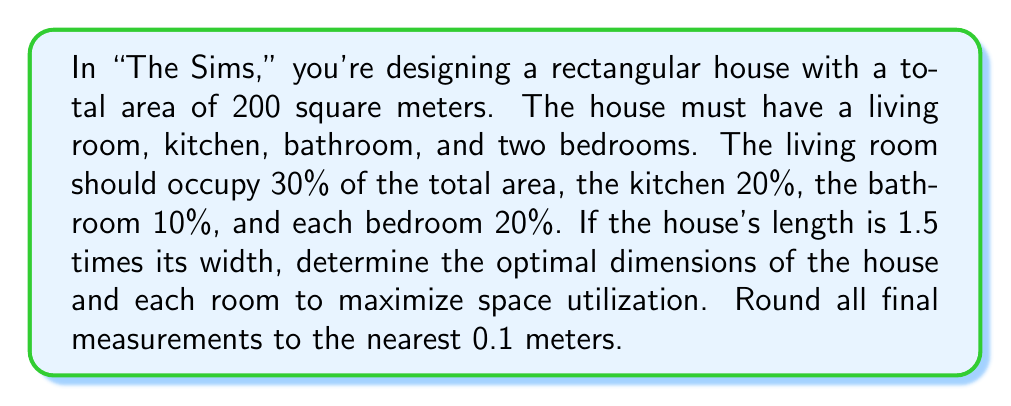Could you help me with this problem? Let's approach this step-by-step:

1) Let the width of the house be $w$ and the length be $l$. We know that:
   $l = 1.5w$

2) The area of the house is given by:
   $A = l \times w = 1.5w \times w = 1.5w^2 = 200$

3) Solving for $w$:
   $w^2 = \frac{200}{1.5} \approx 133.33$
   $w = \sqrt{133.33} \approx 11.5$ meters

4) The length $l$ is then:
   $l = 1.5w = 1.5 \times 11.5 = 17.3$ meters

5) Now, let's calculate the areas of each room:
   Living room: $30\% \text{ of } 200 = 60$ m²
   Kitchen: $20\% \text{ of } 200 = 40$ m²
   Bathroom: $10\% \text{ of } 200 = 20$ m²
   Each bedroom: $20\% \text{ of } 200 = 40$ m²

6) To optimize space utilization, we should make each room as close to square as possible. Let's calculate the dimensions:

   Living room: $\sqrt{60} \approx 7.7$ m × $7.8$ m
   Kitchen: $\sqrt{40} \approx 6.3$ m × $6.3$ m
   Bathroom: $\sqrt{20} \approx 4.5$ m × $4.5$ m
   Each bedroom: $\sqrt{40} \approx 6.3$ m × $6.3$ m

7) These dimensions can be slightly adjusted to fit within the overall house dimensions of 11.5 m × 17.3 m while maintaining their respective areas.
Answer: House: 11.5 m × 17.3 m; Living room: 7.7 m × 7.8 m; Kitchen: 6.3 m × 6.3 m; Bathroom: 4.5 m × 4.5 m; Bedrooms: 6.3 m × 6.3 m each 